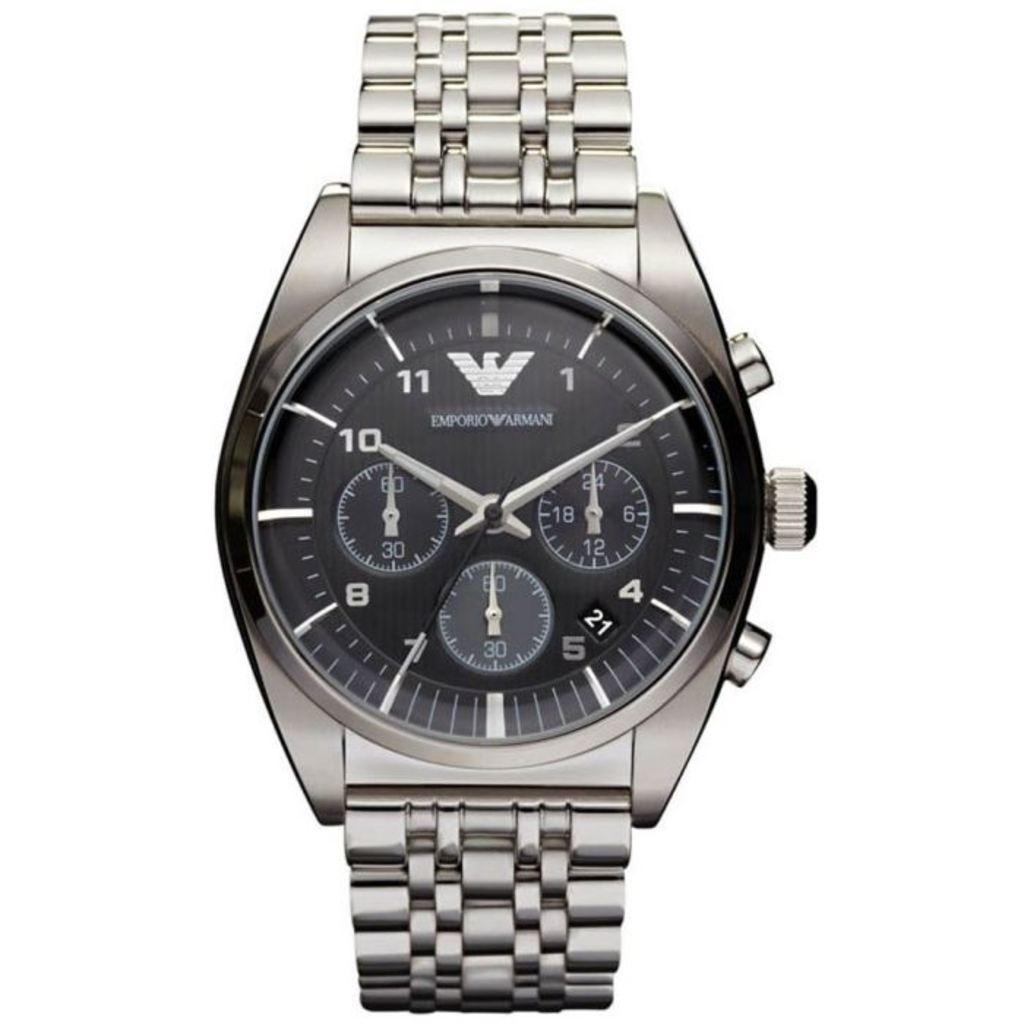<image>
Offer a succinct explanation of the picture presented. A marketing image for an Emporio Armani watch. 